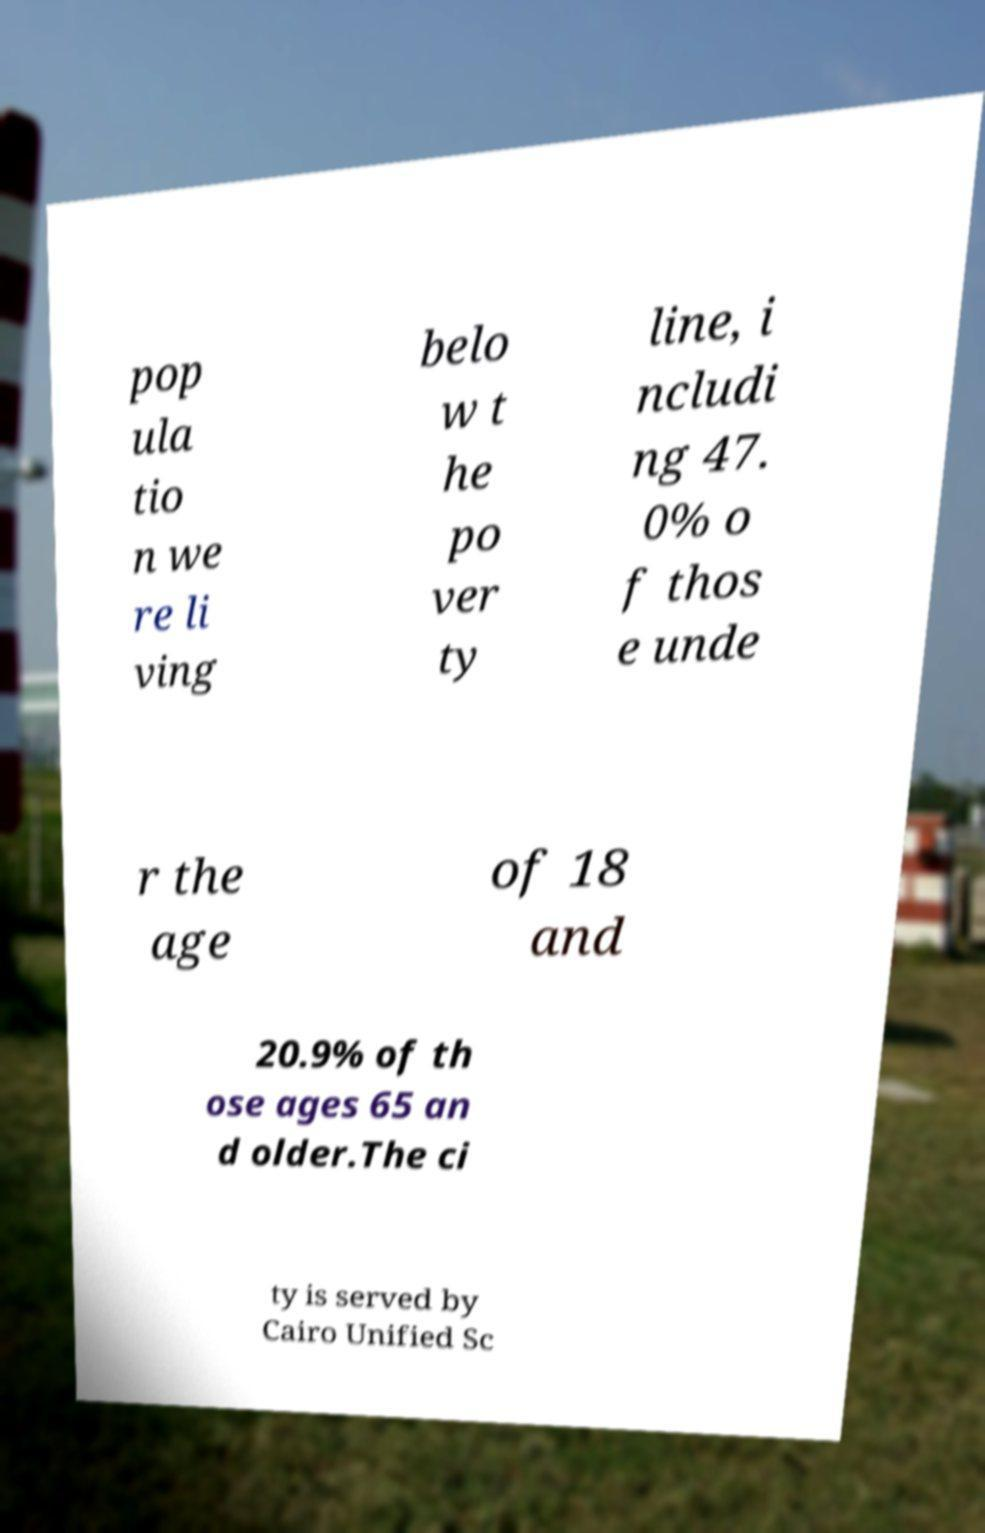For documentation purposes, I need the text within this image transcribed. Could you provide that? pop ula tio n we re li ving belo w t he po ver ty line, i ncludi ng 47. 0% o f thos e unde r the age of 18 and 20.9% of th ose ages 65 an d older.The ci ty is served by Cairo Unified Sc 